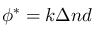<formula> <loc_0><loc_0><loc_500><loc_500>\phi ^ { * } = k \Delta n d</formula> 